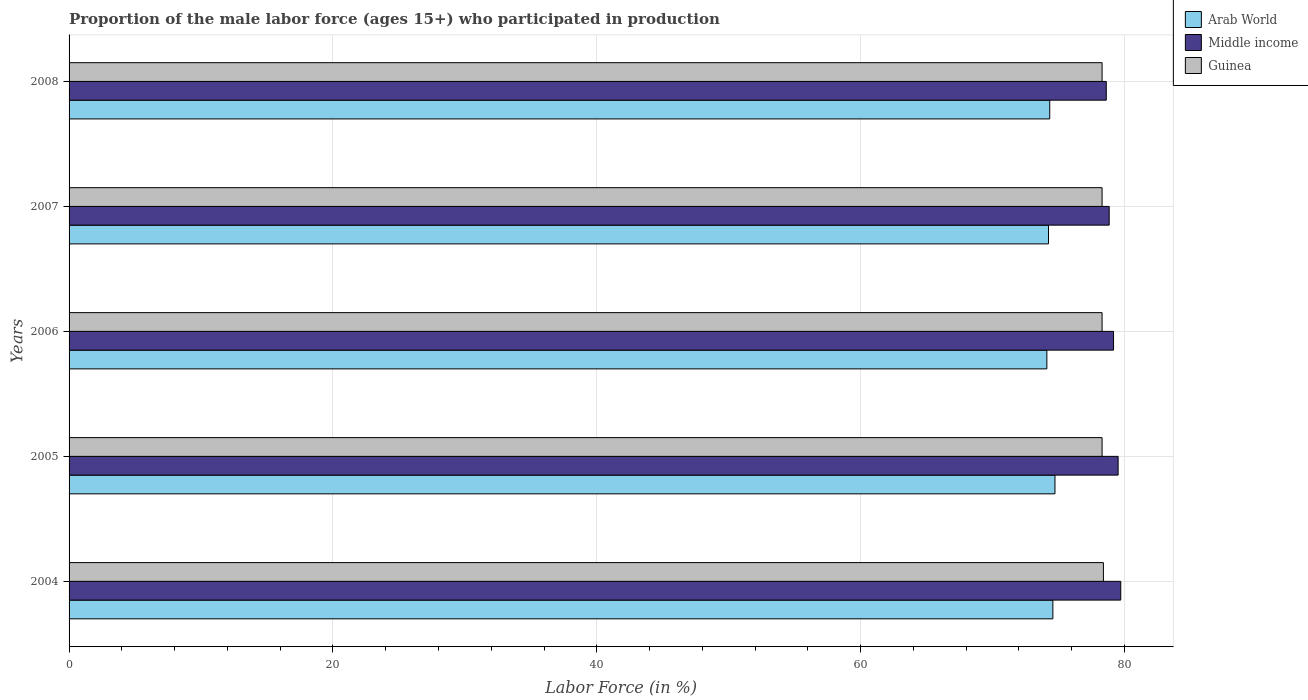How many different coloured bars are there?
Your response must be concise. 3. Are the number of bars on each tick of the Y-axis equal?
Keep it short and to the point. Yes. How many bars are there on the 3rd tick from the bottom?
Provide a succinct answer. 3. What is the label of the 3rd group of bars from the top?
Make the answer very short. 2006. In how many cases, is the number of bars for a given year not equal to the number of legend labels?
Ensure brevity in your answer.  0. What is the proportion of the male labor force who participated in production in Arab World in 2004?
Provide a short and direct response. 74.57. Across all years, what is the maximum proportion of the male labor force who participated in production in Middle income?
Make the answer very short. 79.72. Across all years, what is the minimum proportion of the male labor force who participated in production in Arab World?
Provide a succinct answer. 74.11. In which year was the proportion of the male labor force who participated in production in Arab World maximum?
Your answer should be compact. 2005. In which year was the proportion of the male labor force who participated in production in Middle income minimum?
Offer a terse response. 2008. What is the total proportion of the male labor force who participated in production in Guinea in the graph?
Your answer should be compact. 391.6. What is the difference between the proportion of the male labor force who participated in production in Arab World in 2006 and that in 2007?
Offer a very short reply. -0.12. What is the difference between the proportion of the male labor force who participated in production in Middle income in 2008 and the proportion of the male labor force who participated in production in Guinea in 2007?
Provide a short and direct response. 0.32. What is the average proportion of the male labor force who participated in production in Arab World per year?
Offer a terse response. 74.4. In the year 2004, what is the difference between the proportion of the male labor force who participated in production in Middle income and proportion of the male labor force who participated in production in Arab World?
Your answer should be compact. 5.15. In how many years, is the proportion of the male labor force who participated in production in Arab World greater than 12 %?
Your answer should be very brief. 5. What is the ratio of the proportion of the male labor force who participated in production in Guinea in 2007 to that in 2008?
Provide a short and direct response. 1. Is the proportion of the male labor force who participated in production in Middle income in 2005 less than that in 2007?
Provide a succinct answer. No. Is the difference between the proportion of the male labor force who participated in production in Middle income in 2004 and 2005 greater than the difference between the proportion of the male labor force who participated in production in Arab World in 2004 and 2005?
Your answer should be compact. Yes. What is the difference between the highest and the second highest proportion of the male labor force who participated in production in Arab World?
Provide a succinct answer. 0.16. What is the difference between the highest and the lowest proportion of the male labor force who participated in production in Arab World?
Offer a very short reply. 0.61. In how many years, is the proportion of the male labor force who participated in production in Guinea greater than the average proportion of the male labor force who participated in production in Guinea taken over all years?
Offer a very short reply. 1. Is the sum of the proportion of the male labor force who participated in production in Middle income in 2005 and 2007 greater than the maximum proportion of the male labor force who participated in production in Arab World across all years?
Keep it short and to the point. Yes. What does the 3rd bar from the top in 2005 represents?
Make the answer very short. Arab World. What does the 1st bar from the bottom in 2006 represents?
Offer a terse response. Arab World. Is it the case that in every year, the sum of the proportion of the male labor force who participated in production in Guinea and proportion of the male labor force who participated in production in Arab World is greater than the proportion of the male labor force who participated in production in Middle income?
Offer a terse response. Yes. How many bars are there?
Offer a terse response. 15. Are all the bars in the graph horizontal?
Your answer should be compact. Yes. How many years are there in the graph?
Offer a terse response. 5. What is the difference between two consecutive major ticks on the X-axis?
Your answer should be compact. 20. Does the graph contain grids?
Your answer should be compact. Yes. How many legend labels are there?
Offer a very short reply. 3. What is the title of the graph?
Your answer should be very brief. Proportion of the male labor force (ages 15+) who participated in production. Does "Caribbean small states" appear as one of the legend labels in the graph?
Your answer should be compact. No. What is the label or title of the X-axis?
Make the answer very short. Labor Force (in %). What is the Labor Force (in %) in Arab World in 2004?
Ensure brevity in your answer.  74.57. What is the Labor Force (in %) of Middle income in 2004?
Your answer should be compact. 79.72. What is the Labor Force (in %) of Guinea in 2004?
Your response must be concise. 78.4. What is the Labor Force (in %) of Arab World in 2005?
Give a very brief answer. 74.73. What is the Labor Force (in %) in Middle income in 2005?
Your answer should be very brief. 79.52. What is the Labor Force (in %) of Guinea in 2005?
Offer a terse response. 78.3. What is the Labor Force (in %) in Arab World in 2006?
Your response must be concise. 74.11. What is the Labor Force (in %) in Middle income in 2006?
Make the answer very short. 79.17. What is the Labor Force (in %) of Guinea in 2006?
Give a very brief answer. 78.3. What is the Labor Force (in %) in Arab World in 2007?
Offer a terse response. 74.24. What is the Labor Force (in %) of Middle income in 2007?
Provide a succinct answer. 78.84. What is the Labor Force (in %) of Guinea in 2007?
Provide a short and direct response. 78.3. What is the Labor Force (in %) of Arab World in 2008?
Ensure brevity in your answer.  74.33. What is the Labor Force (in %) in Middle income in 2008?
Offer a very short reply. 78.62. What is the Labor Force (in %) in Guinea in 2008?
Provide a succinct answer. 78.3. Across all years, what is the maximum Labor Force (in %) of Arab World?
Your answer should be very brief. 74.73. Across all years, what is the maximum Labor Force (in %) in Middle income?
Make the answer very short. 79.72. Across all years, what is the maximum Labor Force (in %) of Guinea?
Your answer should be compact. 78.4. Across all years, what is the minimum Labor Force (in %) in Arab World?
Offer a terse response. 74.11. Across all years, what is the minimum Labor Force (in %) in Middle income?
Make the answer very short. 78.62. Across all years, what is the minimum Labor Force (in %) in Guinea?
Offer a very short reply. 78.3. What is the total Labor Force (in %) in Arab World in the graph?
Offer a very short reply. 371.98. What is the total Labor Force (in %) in Middle income in the graph?
Keep it short and to the point. 395.86. What is the total Labor Force (in %) in Guinea in the graph?
Keep it short and to the point. 391.6. What is the difference between the Labor Force (in %) in Arab World in 2004 and that in 2005?
Ensure brevity in your answer.  -0.16. What is the difference between the Labor Force (in %) in Middle income in 2004 and that in 2005?
Your response must be concise. 0.2. What is the difference between the Labor Force (in %) of Arab World in 2004 and that in 2006?
Give a very brief answer. 0.46. What is the difference between the Labor Force (in %) of Middle income in 2004 and that in 2006?
Give a very brief answer. 0.55. What is the difference between the Labor Force (in %) of Arab World in 2004 and that in 2007?
Your response must be concise. 0.33. What is the difference between the Labor Force (in %) in Middle income in 2004 and that in 2007?
Keep it short and to the point. 0.88. What is the difference between the Labor Force (in %) in Arab World in 2004 and that in 2008?
Your response must be concise. 0.24. What is the difference between the Labor Force (in %) of Middle income in 2004 and that in 2008?
Make the answer very short. 1.1. What is the difference between the Labor Force (in %) of Arab World in 2005 and that in 2006?
Give a very brief answer. 0.61. What is the difference between the Labor Force (in %) of Middle income in 2005 and that in 2006?
Your answer should be very brief. 0.35. What is the difference between the Labor Force (in %) in Guinea in 2005 and that in 2006?
Ensure brevity in your answer.  0. What is the difference between the Labor Force (in %) in Arab World in 2005 and that in 2007?
Give a very brief answer. 0.49. What is the difference between the Labor Force (in %) in Middle income in 2005 and that in 2007?
Your answer should be compact. 0.68. What is the difference between the Labor Force (in %) in Guinea in 2005 and that in 2007?
Give a very brief answer. 0. What is the difference between the Labor Force (in %) of Arab World in 2005 and that in 2008?
Your answer should be compact. 0.4. What is the difference between the Labor Force (in %) of Middle income in 2005 and that in 2008?
Provide a succinct answer. 0.9. What is the difference between the Labor Force (in %) of Guinea in 2005 and that in 2008?
Give a very brief answer. 0. What is the difference between the Labor Force (in %) in Arab World in 2006 and that in 2007?
Give a very brief answer. -0.12. What is the difference between the Labor Force (in %) in Middle income in 2006 and that in 2007?
Your answer should be compact. 0.33. What is the difference between the Labor Force (in %) in Guinea in 2006 and that in 2007?
Offer a terse response. 0. What is the difference between the Labor Force (in %) in Arab World in 2006 and that in 2008?
Your response must be concise. -0.22. What is the difference between the Labor Force (in %) in Middle income in 2006 and that in 2008?
Ensure brevity in your answer.  0.55. What is the difference between the Labor Force (in %) of Guinea in 2006 and that in 2008?
Ensure brevity in your answer.  0. What is the difference between the Labor Force (in %) of Arab World in 2007 and that in 2008?
Keep it short and to the point. -0.09. What is the difference between the Labor Force (in %) of Middle income in 2007 and that in 2008?
Provide a short and direct response. 0.22. What is the difference between the Labor Force (in %) in Arab World in 2004 and the Labor Force (in %) in Middle income in 2005?
Provide a succinct answer. -4.95. What is the difference between the Labor Force (in %) of Arab World in 2004 and the Labor Force (in %) of Guinea in 2005?
Keep it short and to the point. -3.73. What is the difference between the Labor Force (in %) of Middle income in 2004 and the Labor Force (in %) of Guinea in 2005?
Ensure brevity in your answer.  1.42. What is the difference between the Labor Force (in %) of Arab World in 2004 and the Labor Force (in %) of Middle income in 2006?
Provide a short and direct response. -4.6. What is the difference between the Labor Force (in %) in Arab World in 2004 and the Labor Force (in %) in Guinea in 2006?
Your answer should be very brief. -3.73. What is the difference between the Labor Force (in %) of Middle income in 2004 and the Labor Force (in %) of Guinea in 2006?
Ensure brevity in your answer.  1.42. What is the difference between the Labor Force (in %) in Arab World in 2004 and the Labor Force (in %) in Middle income in 2007?
Offer a very short reply. -4.27. What is the difference between the Labor Force (in %) in Arab World in 2004 and the Labor Force (in %) in Guinea in 2007?
Make the answer very short. -3.73. What is the difference between the Labor Force (in %) in Middle income in 2004 and the Labor Force (in %) in Guinea in 2007?
Your answer should be compact. 1.42. What is the difference between the Labor Force (in %) of Arab World in 2004 and the Labor Force (in %) of Middle income in 2008?
Your answer should be very brief. -4.05. What is the difference between the Labor Force (in %) in Arab World in 2004 and the Labor Force (in %) in Guinea in 2008?
Offer a terse response. -3.73. What is the difference between the Labor Force (in %) in Middle income in 2004 and the Labor Force (in %) in Guinea in 2008?
Give a very brief answer. 1.42. What is the difference between the Labor Force (in %) of Arab World in 2005 and the Labor Force (in %) of Middle income in 2006?
Offer a terse response. -4.44. What is the difference between the Labor Force (in %) in Arab World in 2005 and the Labor Force (in %) in Guinea in 2006?
Provide a short and direct response. -3.57. What is the difference between the Labor Force (in %) of Middle income in 2005 and the Labor Force (in %) of Guinea in 2006?
Make the answer very short. 1.22. What is the difference between the Labor Force (in %) in Arab World in 2005 and the Labor Force (in %) in Middle income in 2007?
Your response must be concise. -4.11. What is the difference between the Labor Force (in %) in Arab World in 2005 and the Labor Force (in %) in Guinea in 2007?
Provide a succinct answer. -3.57. What is the difference between the Labor Force (in %) in Middle income in 2005 and the Labor Force (in %) in Guinea in 2007?
Offer a very short reply. 1.22. What is the difference between the Labor Force (in %) of Arab World in 2005 and the Labor Force (in %) of Middle income in 2008?
Your answer should be very brief. -3.89. What is the difference between the Labor Force (in %) of Arab World in 2005 and the Labor Force (in %) of Guinea in 2008?
Provide a succinct answer. -3.57. What is the difference between the Labor Force (in %) of Middle income in 2005 and the Labor Force (in %) of Guinea in 2008?
Your response must be concise. 1.22. What is the difference between the Labor Force (in %) of Arab World in 2006 and the Labor Force (in %) of Middle income in 2007?
Offer a very short reply. -4.73. What is the difference between the Labor Force (in %) in Arab World in 2006 and the Labor Force (in %) in Guinea in 2007?
Your response must be concise. -4.19. What is the difference between the Labor Force (in %) in Middle income in 2006 and the Labor Force (in %) in Guinea in 2007?
Your answer should be compact. 0.87. What is the difference between the Labor Force (in %) in Arab World in 2006 and the Labor Force (in %) in Middle income in 2008?
Provide a succinct answer. -4.5. What is the difference between the Labor Force (in %) in Arab World in 2006 and the Labor Force (in %) in Guinea in 2008?
Give a very brief answer. -4.19. What is the difference between the Labor Force (in %) in Middle income in 2006 and the Labor Force (in %) in Guinea in 2008?
Make the answer very short. 0.87. What is the difference between the Labor Force (in %) of Arab World in 2007 and the Labor Force (in %) of Middle income in 2008?
Provide a short and direct response. -4.38. What is the difference between the Labor Force (in %) of Arab World in 2007 and the Labor Force (in %) of Guinea in 2008?
Offer a very short reply. -4.06. What is the difference between the Labor Force (in %) of Middle income in 2007 and the Labor Force (in %) of Guinea in 2008?
Offer a terse response. 0.54. What is the average Labor Force (in %) in Arab World per year?
Offer a terse response. 74.4. What is the average Labor Force (in %) in Middle income per year?
Offer a very short reply. 79.17. What is the average Labor Force (in %) in Guinea per year?
Provide a short and direct response. 78.32. In the year 2004, what is the difference between the Labor Force (in %) in Arab World and Labor Force (in %) in Middle income?
Ensure brevity in your answer.  -5.15. In the year 2004, what is the difference between the Labor Force (in %) in Arab World and Labor Force (in %) in Guinea?
Offer a very short reply. -3.83. In the year 2004, what is the difference between the Labor Force (in %) in Middle income and Labor Force (in %) in Guinea?
Your answer should be very brief. 1.32. In the year 2005, what is the difference between the Labor Force (in %) of Arab World and Labor Force (in %) of Middle income?
Your answer should be compact. -4.79. In the year 2005, what is the difference between the Labor Force (in %) of Arab World and Labor Force (in %) of Guinea?
Offer a very short reply. -3.57. In the year 2005, what is the difference between the Labor Force (in %) in Middle income and Labor Force (in %) in Guinea?
Provide a succinct answer. 1.22. In the year 2006, what is the difference between the Labor Force (in %) of Arab World and Labor Force (in %) of Middle income?
Provide a succinct answer. -5.05. In the year 2006, what is the difference between the Labor Force (in %) in Arab World and Labor Force (in %) in Guinea?
Your response must be concise. -4.19. In the year 2006, what is the difference between the Labor Force (in %) of Middle income and Labor Force (in %) of Guinea?
Offer a very short reply. 0.87. In the year 2007, what is the difference between the Labor Force (in %) of Arab World and Labor Force (in %) of Middle income?
Provide a short and direct response. -4.6. In the year 2007, what is the difference between the Labor Force (in %) of Arab World and Labor Force (in %) of Guinea?
Provide a succinct answer. -4.06. In the year 2007, what is the difference between the Labor Force (in %) of Middle income and Labor Force (in %) of Guinea?
Give a very brief answer. 0.54. In the year 2008, what is the difference between the Labor Force (in %) in Arab World and Labor Force (in %) in Middle income?
Provide a short and direct response. -4.29. In the year 2008, what is the difference between the Labor Force (in %) in Arab World and Labor Force (in %) in Guinea?
Provide a short and direct response. -3.97. In the year 2008, what is the difference between the Labor Force (in %) of Middle income and Labor Force (in %) of Guinea?
Give a very brief answer. 0.32. What is the ratio of the Labor Force (in %) in Arab World in 2004 to that in 2006?
Provide a succinct answer. 1.01. What is the ratio of the Labor Force (in %) in Middle income in 2004 to that in 2006?
Your answer should be compact. 1.01. What is the ratio of the Labor Force (in %) in Arab World in 2004 to that in 2007?
Ensure brevity in your answer.  1. What is the ratio of the Labor Force (in %) in Middle income in 2004 to that in 2007?
Your answer should be very brief. 1.01. What is the ratio of the Labor Force (in %) of Arab World in 2004 to that in 2008?
Make the answer very short. 1. What is the ratio of the Labor Force (in %) in Arab World in 2005 to that in 2006?
Provide a short and direct response. 1.01. What is the ratio of the Labor Force (in %) in Guinea in 2005 to that in 2006?
Ensure brevity in your answer.  1. What is the ratio of the Labor Force (in %) of Arab World in 2005 to that in 2007?
Your answer should be compact. 1.01. What is the ratio of the Labor Force (in %) in Middle income in 2005 to that in 2007?
Your answer should be very brief. 1.01. What is the ratio of the Labor Force (in %) in Middle income in 2005 to that in 2008?
Your response must be concise. 1.01. What is the ratio of the Labor Force (in %) of Guinea in 2005 to that in 2008?
Keep it short and to the point. 1. What is the ratio of the Labor Force (in %) in Arab World in 2006 to that in 2007?
Your answer should be very brief. 1. What is the ratio of the Labor Force (in %) in Guinea in 2006 to that in 2008?
Your answer should be very brief. 1. What is the ratio of the Labor Force (in %) in Arab World in 2007 to that in 2008?
Your answer should be compact. 1. What is the ratio of the Labor Force (in %) in Middle income in 2007 to that in 2008?
Offer a terse response. 1. What is the ratio of the Labor Force (in %) in Guinea in 2007 to that in 2008?
Your answer should be compact. 1. What is the difference between the highest and the second highest Labor Force (in %) in Arab World?
Ensure brevity in your answer.  0.16. What is the difference between the highest and the second highest Labor Force (in %) of Guinea?
Offer a very short reply. 0.1. What is the difference between the highest and the lowest Labor Force (in %) of Arab World?
Your response must be concise. 0.61. What is the difference between the highest and the lowest Labor Force (in %) of Middle income?
Offer a terse response. 1.1. 